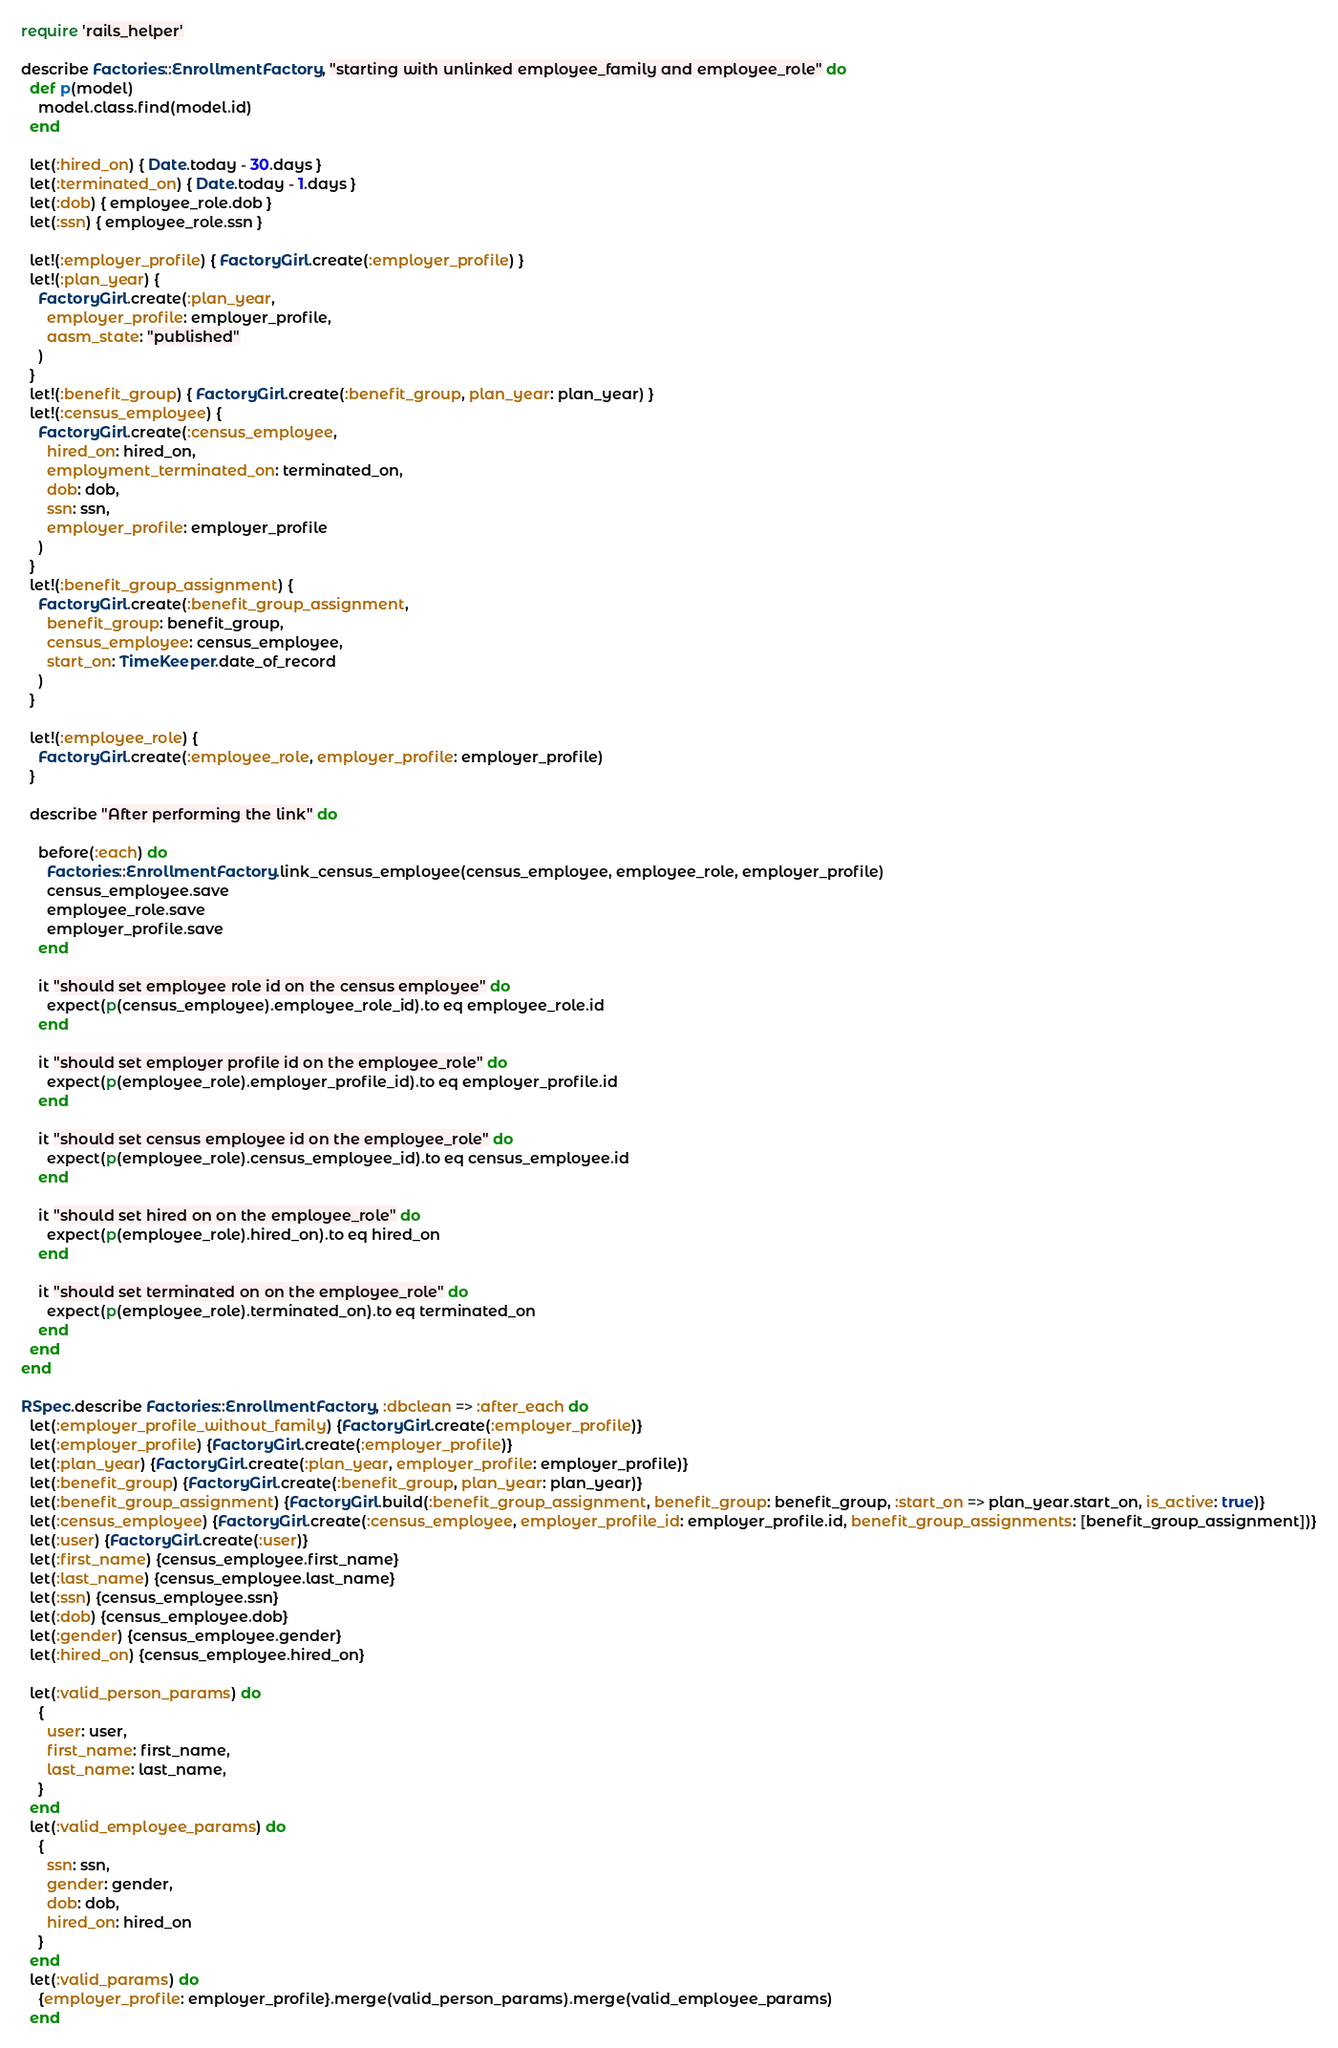<code> <loc_0><loc_0><loc_500><loc_500><_Ruby_>require 'rails_helper'

describe Factories::EnrollmentFactory, "starting with unlinked employee_family and employee_role" do
  def p(model)
    model.class.find(model.id)
  end

  let(:hired_on) { Date.today - 30.days }
  let(:terminated_on) { Date.today - 1.days }
  let(:dob) { employee_role.dob }
  let(:ssn) { employee_role.ssn }

  let!(:employer_profile) { FactoryGirl.create(:employer_profile) }
  let!(:plan_year) {
    FactoryGirl.create(:plan_year,
      employer_profile: employer_profile,
      aasm_state: "published"
    )
  }
  let!(:benefit_group) { FactoryGirl.create(:benefit_group, plan_year: plan_year) }
  let!(:census_employee) {
    FactoryGirl.create(:census_employee,
      hired_on: hired_on,
      employment_terminated_on: terminated_on,
      dob: dob,
      ssn: ssn,
      employer_profile: employer_profile
    )
  }
  let!(:benefit_group_assignment) {
    FactoryGirl.create(:benefit_group_assignment,
      benefit_group: benefit_group,
      census_employee: census_employee,
      start_on: TimeKeeper.date_of_record
    )
  }

  let!(:employee_role) {
    FactoryGirl.create(:employee_role, employer_profile: employer_profile)
  }

  describe "After performing the link" do

    before(:each) do
      Factories::EnrollmentFactory.link_census_employee(census_employee, employee_role, employer_profile)
      census_employee.save
      employee_role.save
      employer_profile.save
    end

    it "should set employee role id on the census employee" do
      expect(p(census_employee).employee_role_id).to eq employee_role.id
    end

    it "should set employer profile id on the employee_role" do
      expect(p(employee_role).employer_profile_id).to eq employer_profile.id
    end

    it "should set census employee id on the employee_role" do
      expect(p(employee_role).census_employee_id).to eq census_employee.id
    end

    it "should set hired on on the employee_role" do
      expect(p(employee_role).hired_on).to eq hired_on
    end

    it "should set terminated on on the employee_role" do
      expect(p(employee_role).terminated_on).to eq terminated_on
    end
  end
end

RSpec.describe Factories::EnrollmentFactory, :dbclean => :after_each do
  let(:employer_profile_without_family) {FactoryGirl.create(:employer_profile)}
  let(:employer_profile) {FactoryGirl.create(:employer_profile)}
  let(:plan_year) {FactoryGirl.create(:plan_year, employer_profile: employer_profile)}
  let(:benefit_group) {FactoryGirl.create(:benefit_group, plan_year: plan_year)}
  let(:benefit_group_assignment) {FactoryGirl.build(:benefit_group_assignment, benefit_group: benefit_group, :start_on => plan_year.start_on, is_active: true)}
  let(:census_employee) {FactoryGirl.create(:census_employee, employer_profile_id: employer_profile.id, benefit_group_assignments: [benefit_group_assignment])}
  let(:user) {FactoryGirl.create(:user)}
  let(:first_name) {census_employee.first_name}
  let(:last_name) {census_employee.last_name}
  let(:ssn) {census_employee.ssn}
  let(:dob) {census_employee.dob}
  let(:gender) {census_employee.gender}
  let(:hired_on) {census_employee.hired_on}

  let(:valid_person_params) do
    {
      user: user,
      first_name: first_name,
      last_name: last_name,
    }
  end
  let(:valid_employee_params) do
    {
      ssn: ssn,
      gender: gender,
      dob: dob,
      hired_on: hired_on
    }
  end
  let(:valid_params) do
    {employer_profile: employer_profile}.merge(valid_person_params).merge(valid_employee_params)
  end
</code> 